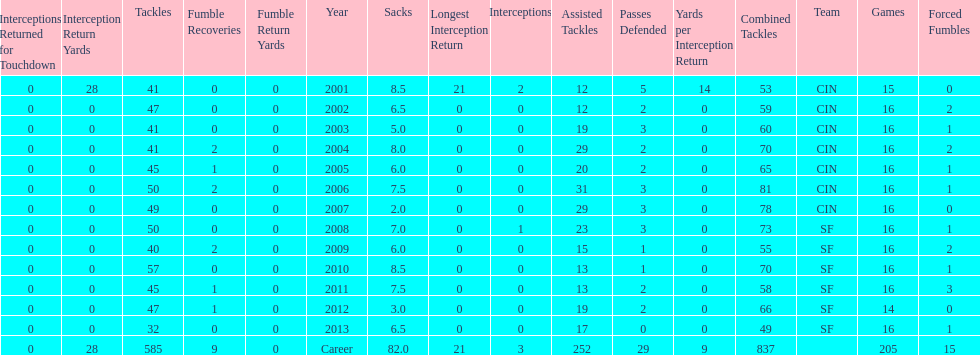How many years did he play where he did not recover a fumble? 7. 